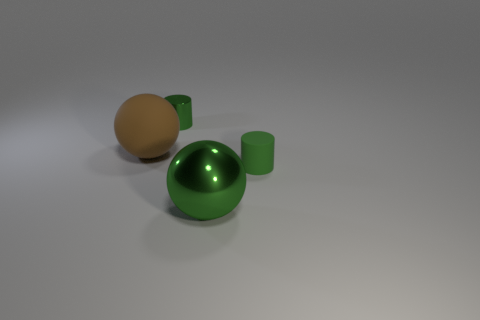What number of spheres are either matte things or metallic objects?
Your answer should be very brief. 2. The small rubber thing has what color?
Offer a terse response. Green. Are there more green shiny balls than small green cylinders?
Offer a very short reply. No. What number of things are green things that are to the left of the green matte object or brown things?
Provide a succinct answer. 3. Is the brown thing made of the same material as the large green sphere?
Your response must be concise. No. What is the size of the other green thing that is the same shape as the small metal object?
Offer a very short reply. Small. Do the metallic object that is in front of the matte cylinder and the big object that is to the left of the small green shiny cylinder have the same shape?
Your response must be concise. Yes. Does the green metal ball have the same size as the matte object behind the small green rubber thing?
Keep it short and to the point. Yes. How many other things are the same material as the brown object?
Provide a short and direct response. 1. What is the color of the thing to the right of the metallic thing that is in front of the matte object right of the big matte object?
Provide a succinct answer. Green. 